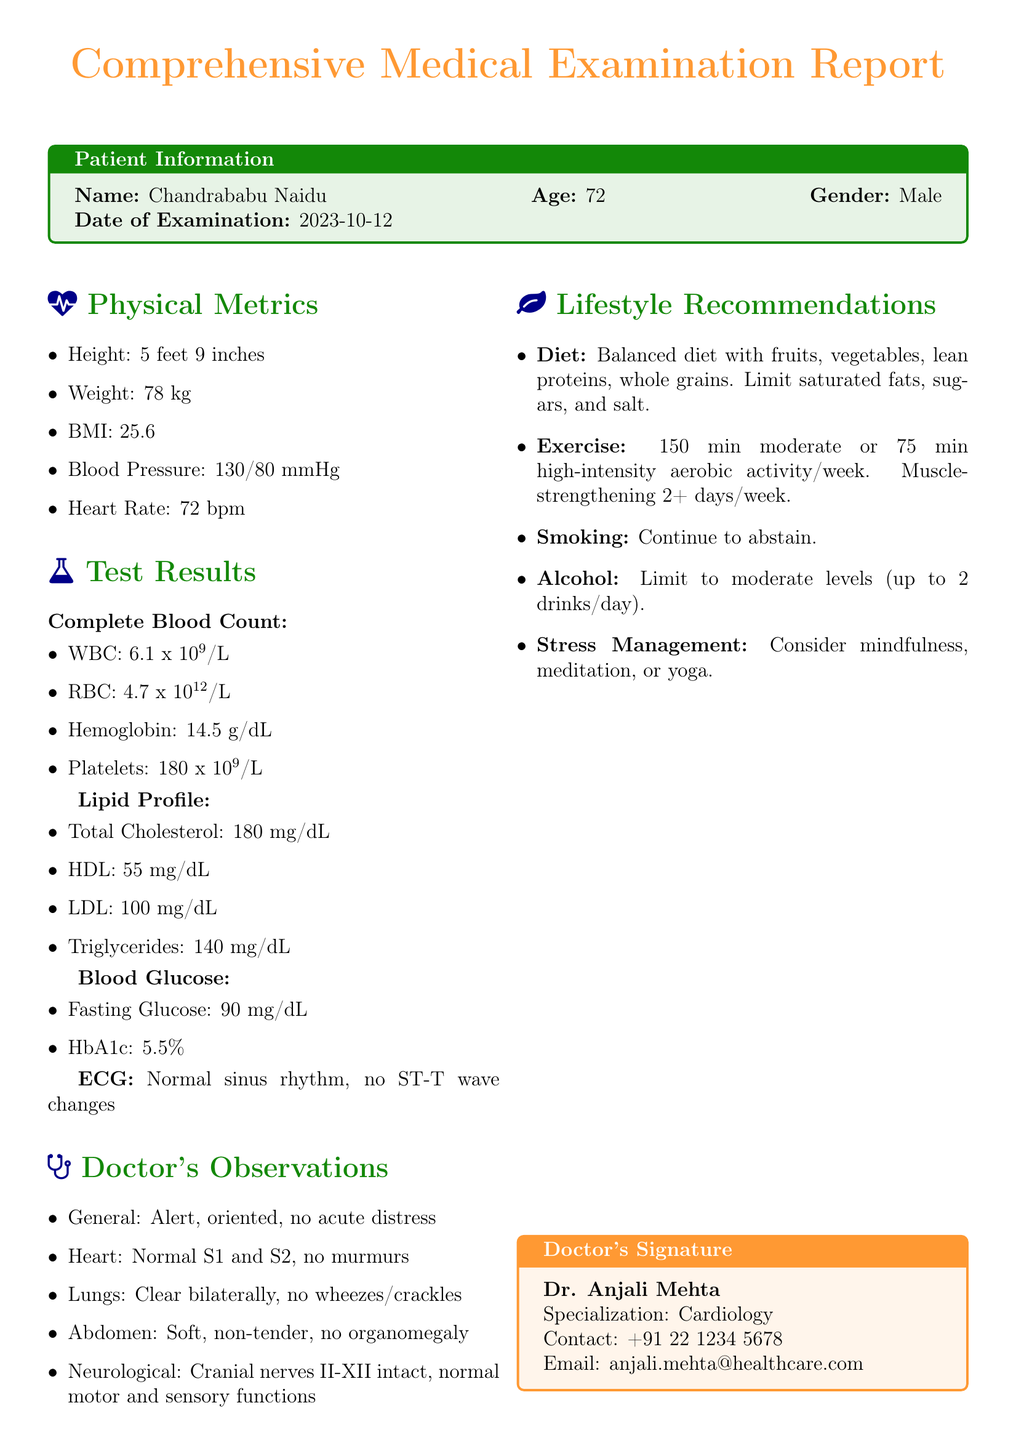What is the name of the patient? The document explicitly states the patient's name at the top in the Patient Information section.
Answer: Chandrababu Naidu What is the age of the patient? The document specifies the age of the patient in the Patient Information section.
Answer: 72 What is the date of examination? The date of examination is clearly mentioned in the Patient Information section.
Answer: 2023-10-12 What is the patient's BMI? The patient's BMI is provided in the Physical Metrics section of the document.
Answer: 25.6 What were the total cholesterol levels? Total cholesterol levels are indicated under the Lipid Profile test results in the document.
Answer: 180 mg/dL How many minutes of exercise is recommended per week? The exercise recommendation states the number of minutes in the Lifestyle Recommendations section.
Answer: 150 min What is the doctor's specialization? The doctor's specialization is mentioned in the Doctor's Signature box at the end of the document.
Answer: Cardiology Is the ECG result normal or abnormal? The ECG result is explicitly stated in the Test Results section of the document.
Answer: Normal What should be limited in alcohol consumption? The Lifestyle Recommendations specify the limitations regarding alcohol consumption.
Answer: Moderate levels (up to 2 drinks/day) What is the patient's heart rate? The heart rate is detailed in the Physical Metrics section of the document.
Answer: 72 bpm 